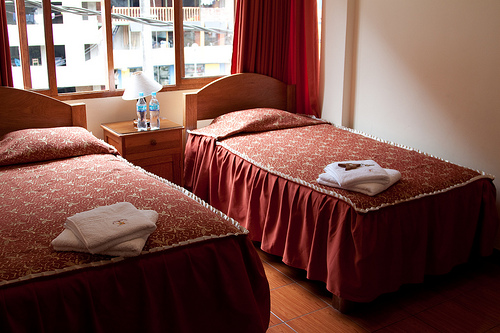Please provide the bounding box coordinate of the region this sentence describes: bedroom night stand. The bounding box coordinates for a night stand located against the room's wall between the beds are [0.2, 0.39, 0.43, 0.59]. It appears to have a reading lamp and a telephone. 